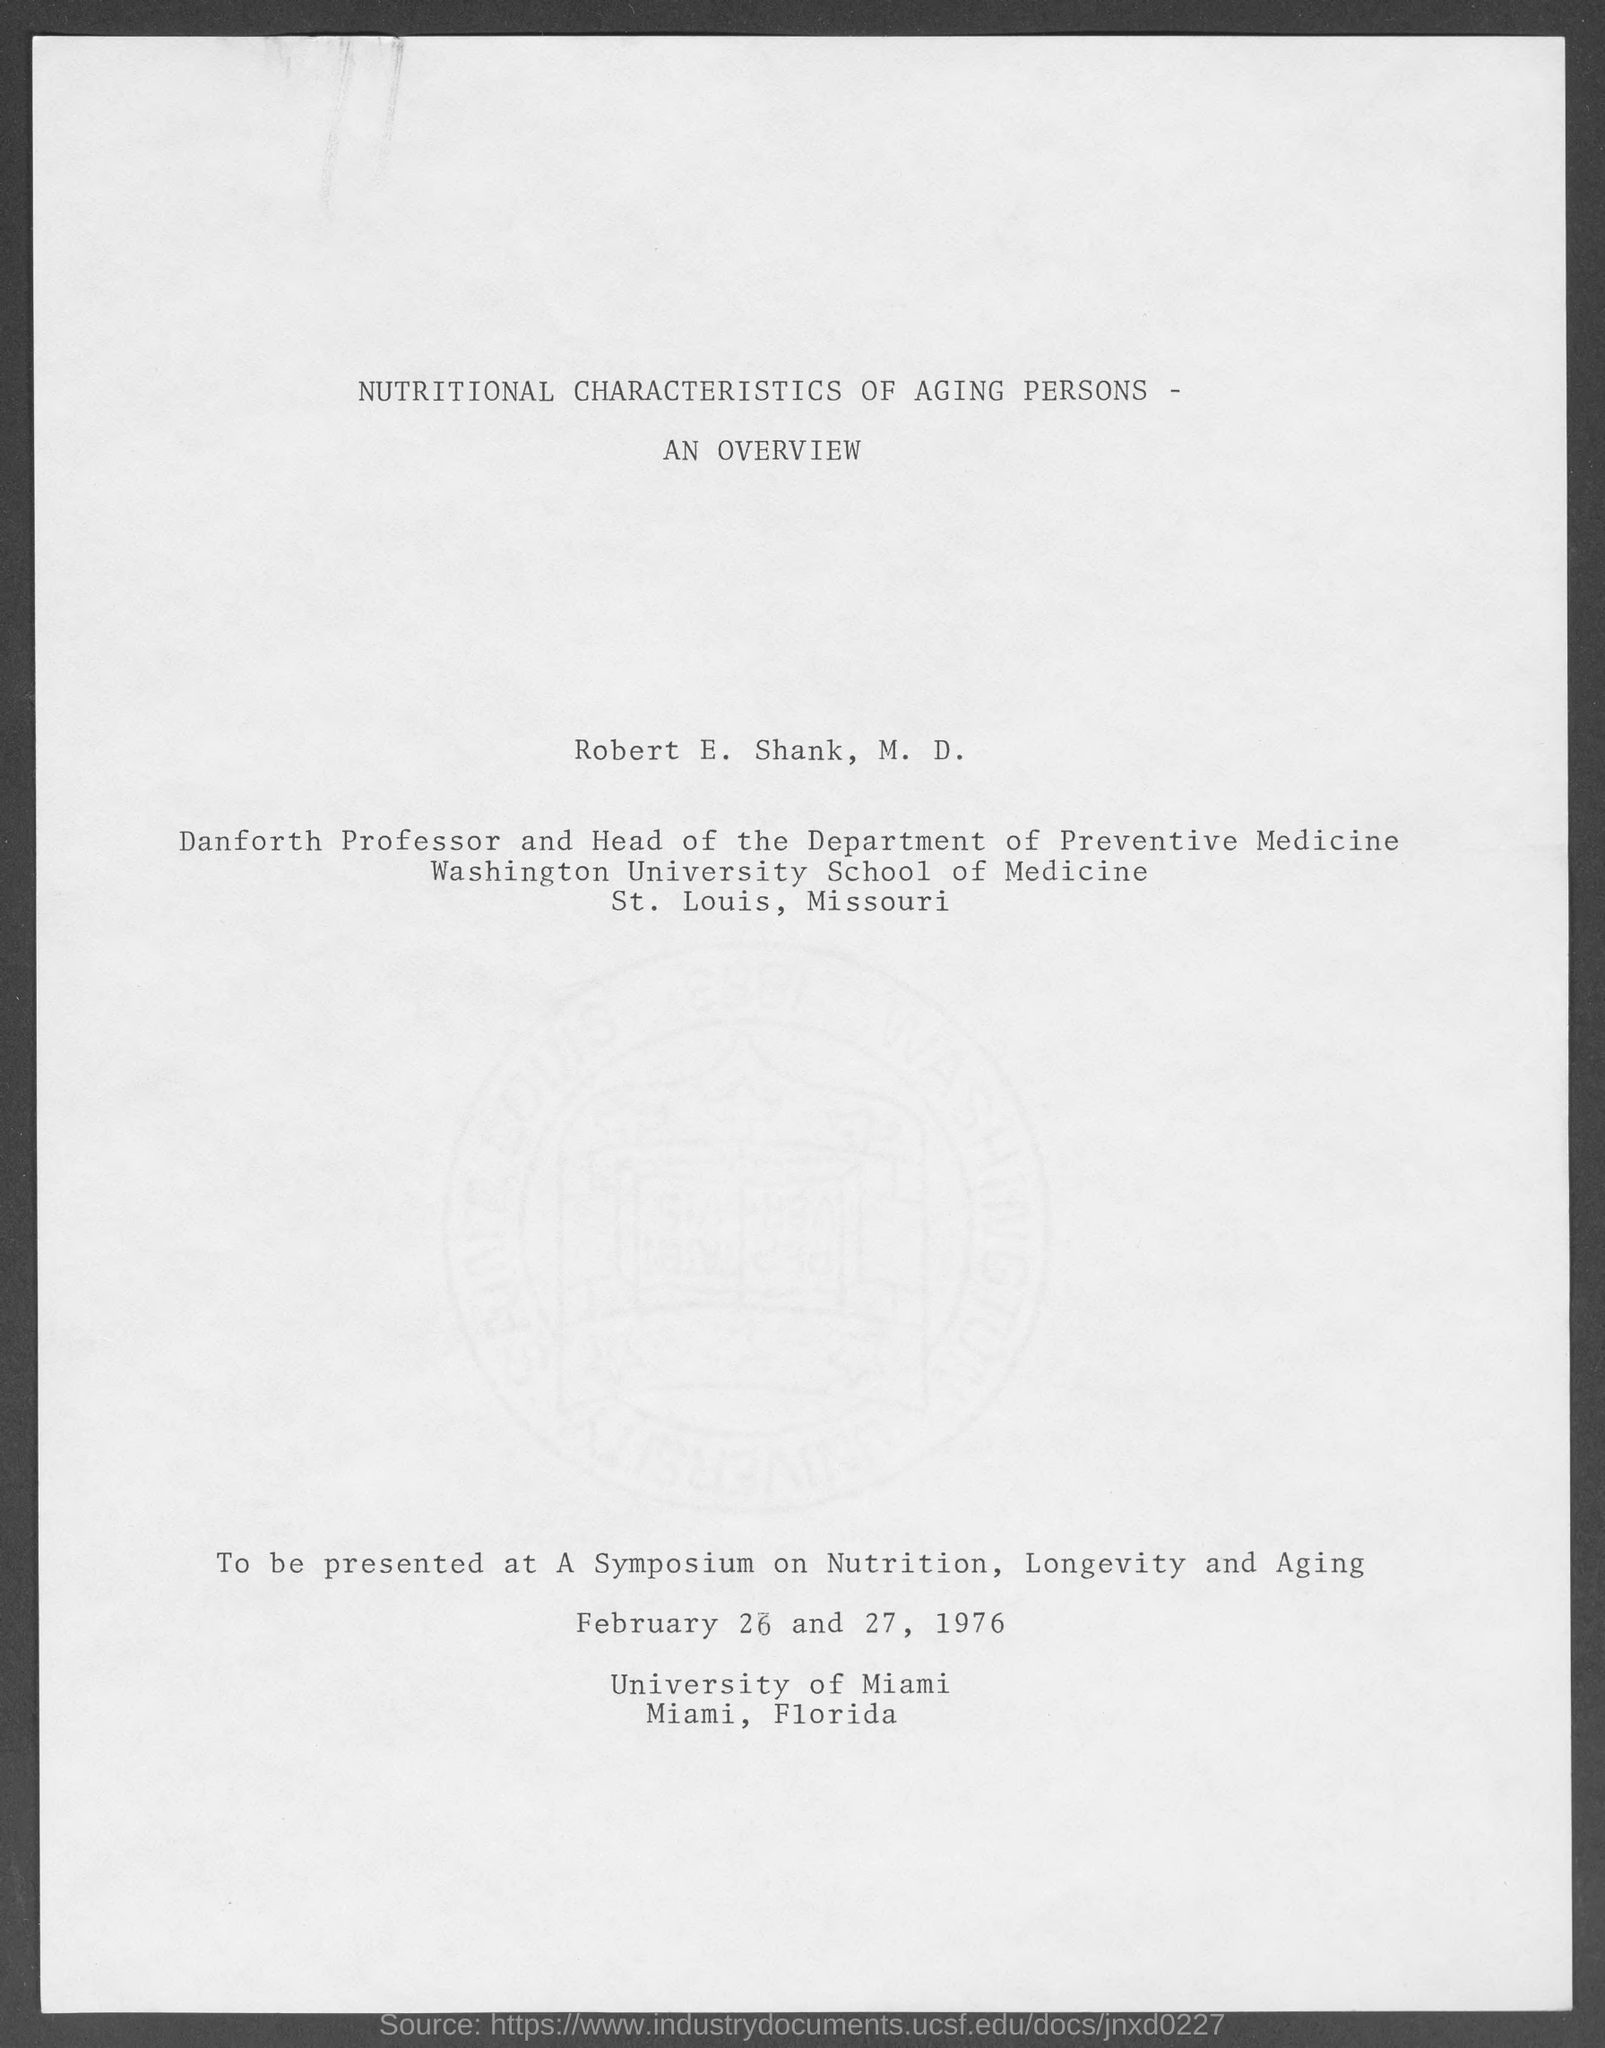Indicate a few pertinent items in this graphic. The title of the document is 'Nutritional Characteristics of Aging Persons - An Overview.' The head of the Department of Preventive Medicine is Robert E. Shank. 